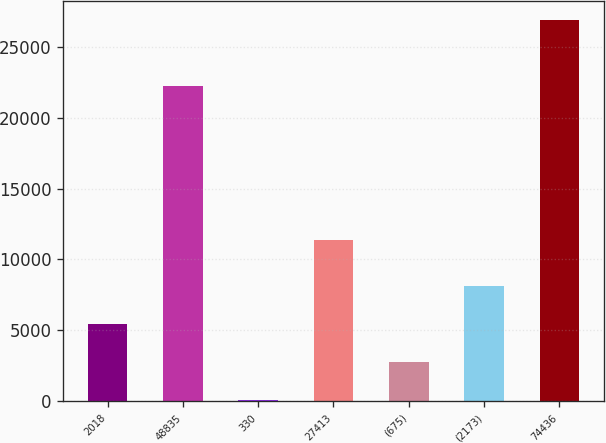Convert chart. <chart><loc_0><loc_0><loc_500><loc_500><bar_chart><fcel>2018<fcel>48835<fcel>330<fcel>27413<fcel>(675)<fcel>(2173)<fcel>74436<nl><fcel>5419.8<fcel>22239<fcel>46<fcel>11359<fcel>2732.9<fcel>8106.7<fcel>26915<nl></chart> 